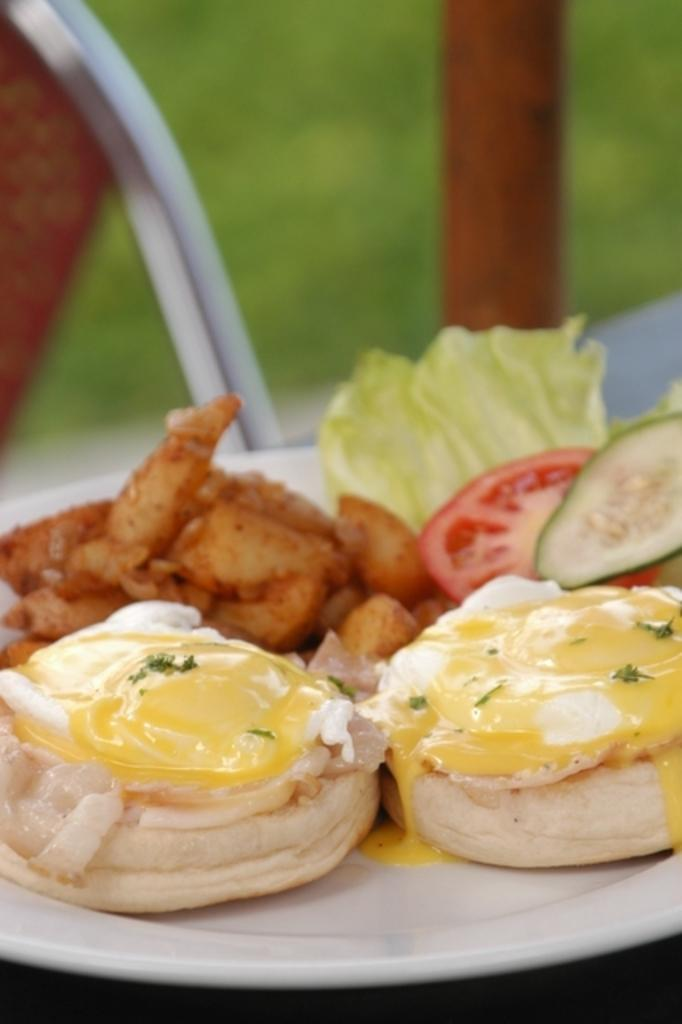What is on the plate that is visible in the image? There is food on a plate in the image. Can you describe the background of the image? The background of the image is blurry. What can be seen in the center of the image? There are objects in the center of the image. What colors are these objects? These objects are white and brown in color. Is there a river flowing through the tent in the image? There is no tent or river present in the image. Can you see any airplanes taking off or landing at the airport in the image? There is no airport present in the image. 